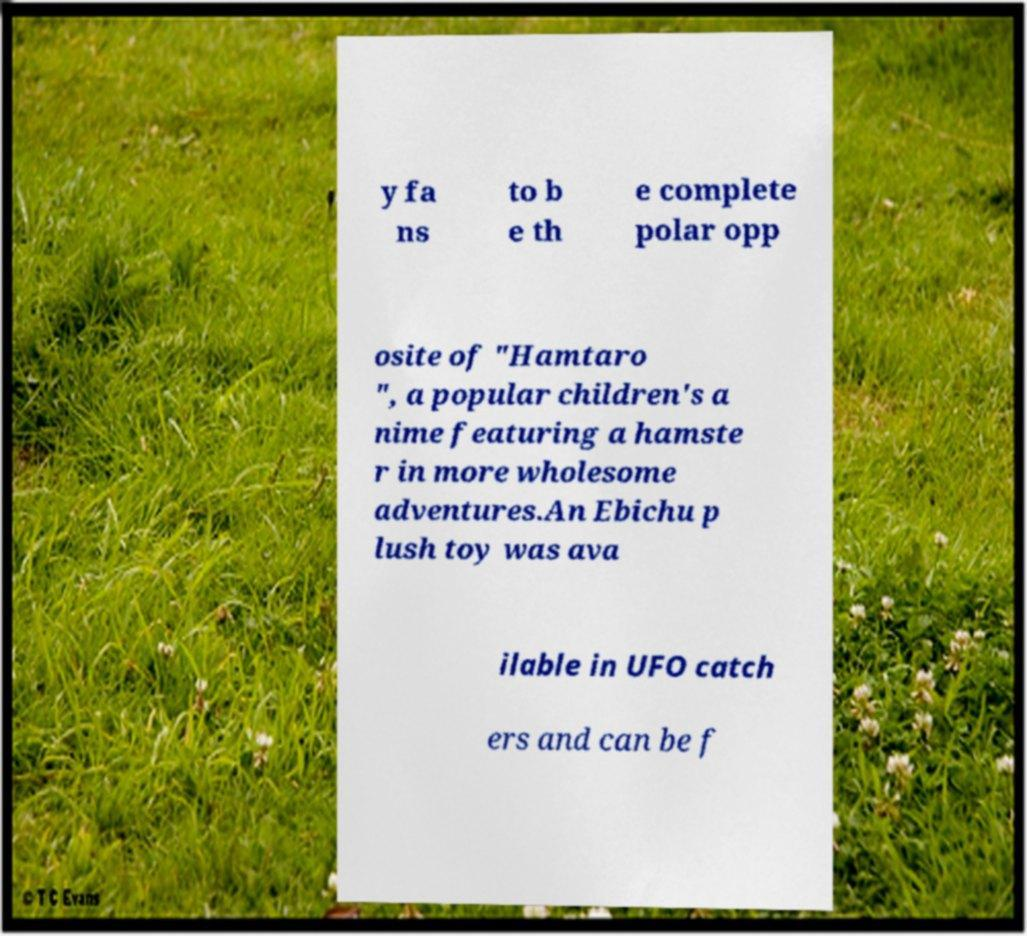For documentation purposes, I need the text within this image transcribed. Could you provide that? y fa ns to b e th e complete polar opp osite of "Hamtaro ", a popular children's a nime featuring a hamste r in more wholesome adventures.An Ebichu p lush toy was ava ilable in UFO catch ers and can be f 